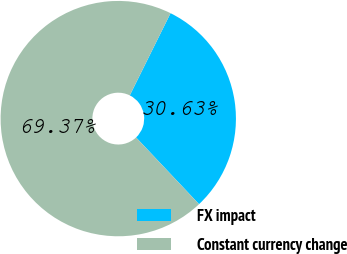Convert chart to OTSL. <chart><loc_0><loc_0><loc_500><loc_500><pie_chart><fcel>FX impact<fcel>Constant currency change<nl><fcel>30.63%<fcel>69.37%<nl></chart> 